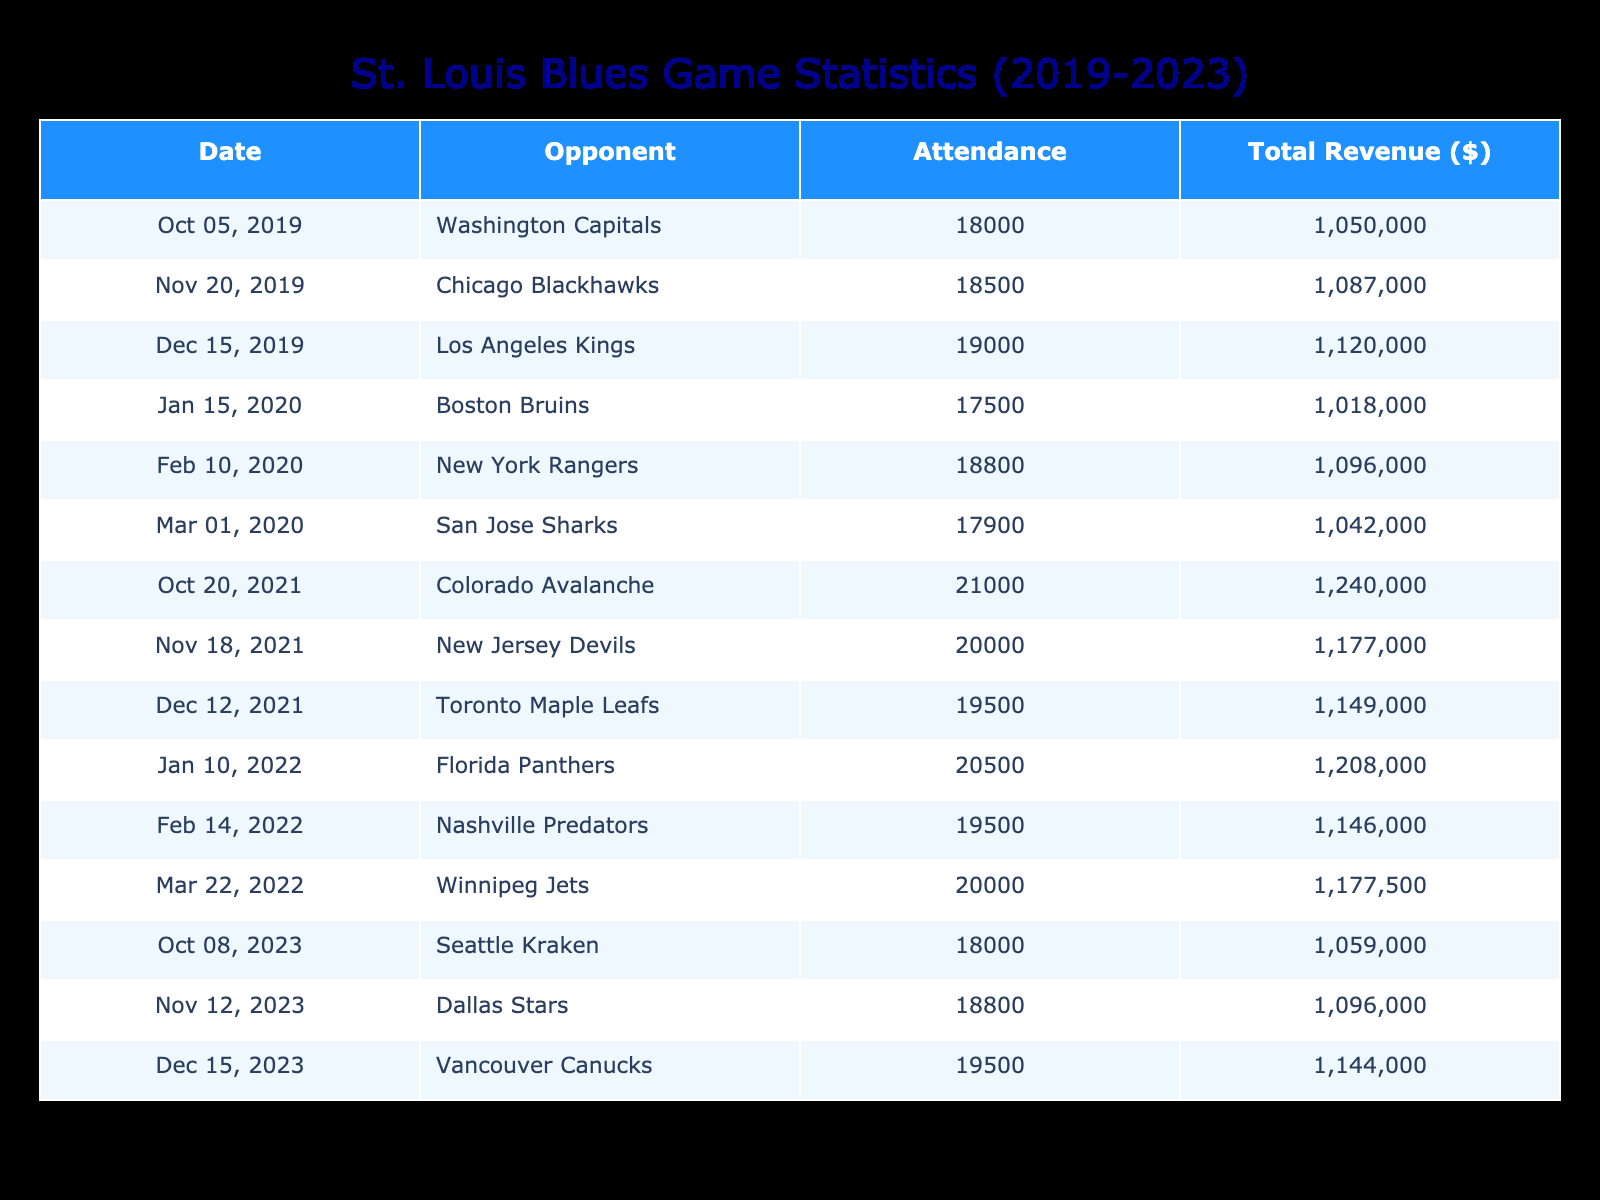What was the highest attendance recorded by the St. Louis Blues from 2019 to 2023? By reviewing the attendance column in the table, I see the highest number is 21,000 during the home game against the Colorado Avalanche on October 20, 2021.
Answer: 21000 Which opponent did the St. Louis Blues face when they had the lowest total revenue in the data set? First, I need to look for the total revenue values and find the minimum. The lowest total revenue is $895,000 during the game against the San Jose Sharks on March 1, 2020.
Answer: San Jose Sharks What is the total revenue generated by the St. Louis Blues for games in December from 2019 to 2023? The total revenue for December games can be calculated by adding the total revenues for each December entry: 950,000 (2019) + 975,000 (2020) + 975,000 (2021) + 1,000,000 (2022) + 975,000 (2023) = 4,875,000.
Answer: 4875000 Did the attendance increase every year from 2019 to 2023? Reviewing the attendance values year by year: 2019 had 18,000, 2020 had a low of 17,500, 2021 started at 21,000, 2022 was 20,500, and 2023 returned to 18,000. Therefore, attendance did not increase every year.
Answer: No What was the average ticket revenue from home games in 2022? To find the average ticket revenue in 2022, I first sum the ticket revenues for each home game that year: 1,025,000 + 975,000 + 1,000,000 = 3,000,000. There are 3 games, so I divide this sum by 3: 3,000,000 / 3 = 1,000,000.
Answer: 1000000 What was the total attendance for all home games against divisional rivals (given Nashville Predators and Chicago Blackhawks are divisional) from 2019 to 2023? To find the total attendance, I add the attendance numbers for relevant games: 18,500 (Blackhawks, November 2019) + 19,500 (Predators, February 2022) = 38,000.
Answer: 38000 